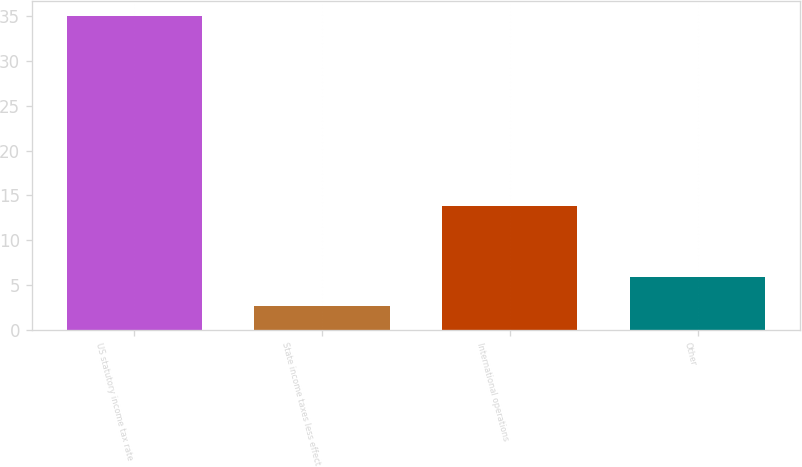Convert chart. <chart><loc_0><loc_0><loc_500><loc_500><bar_chart><fcel>US statutory income tax rate<fcel>State income taxes less effect<fcel>International operations<fcel>Other<nl><fcel>35<fcel>2.6<fcel>13.8<fcel>5.84<nl></chart> 